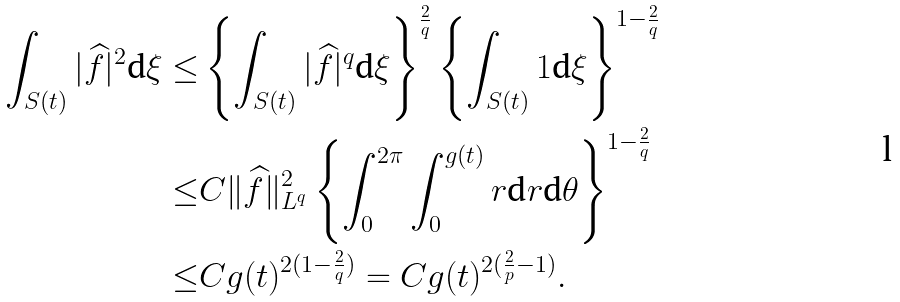<formula> <loc_0><loc_0><loc_500><loc_500>\int _ { S ( t ) } | \widehat { f } | ^ { 2 } \text {d} \xi \leq & \left \{ \int _ { S ( t ) } | \widehat { f } | ^ { q } \text {d} \xi \right \} ^ { \frac { 2 } { q } } \left \{ \int _ { S ( t ) } 1 \text {d} \xi \right \} ^ { 1 - \frac { 2 } { q } } \\ \leq & C \| \widehat { f } \| _ { L ^ { q } } ^ { 2 } \left \{ \int _ { 0 } ^ { 2 \pi } \int _ { 0 } ^ { g ( t ) } r \text {d} r \text {d} \theta \right \} ^ { 1 - \frac { 2 } { q } } \\ \leq & C g ( t ) ^ { 2 ( 1 - \frac { 2 } { q } ) } = C g ( t ) ^ { 2 ( \frac { 2 } { p } - 1 ) } .</formula> 